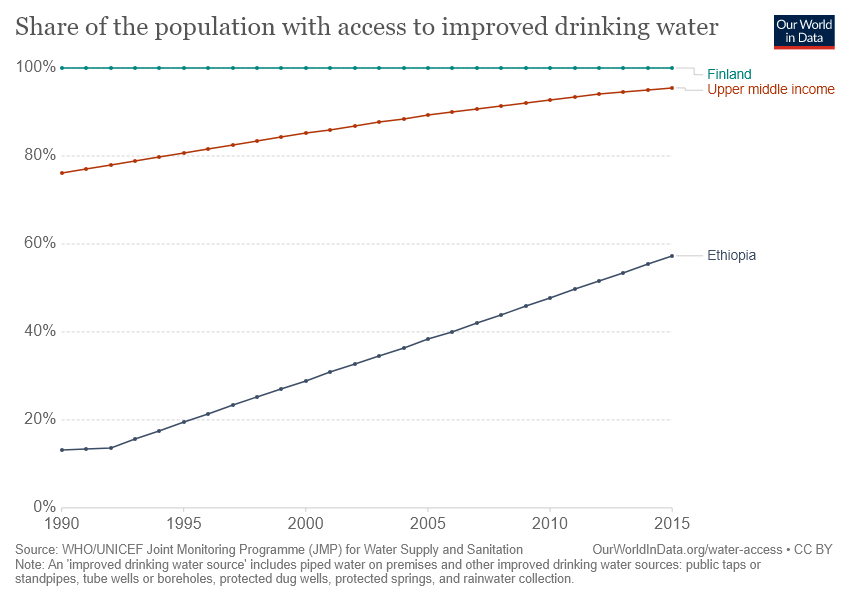Highlight a few significant elements in this photo. In Ethiopia, the access to improved drinking water increased by more than 40% in how many years? Finland has consistently had the highest access to improved drinking water over the years. 